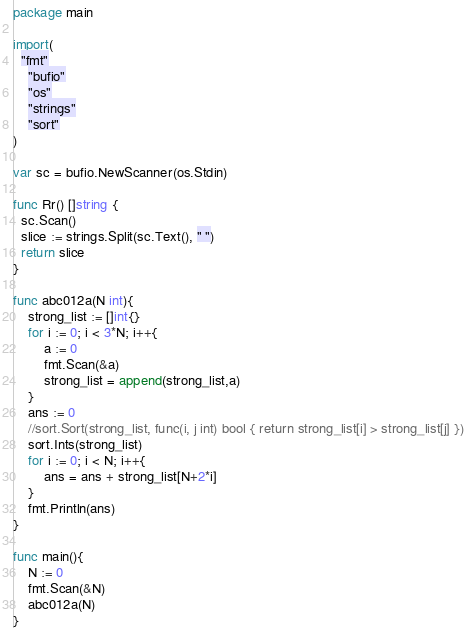<code> <loc_0><loc_0><loc_500><loc_500><_Go_>package main
 
import(
  "fmt"
	"bufio"
	"os"
	"strings"
	"sort"
)
 
var sc = bufio.NewScanner(os.Stdin)
 
func Rr() []string {
  sc.Scan()
  slice := strings.Split(sc.Text(), " ")
  return slice
}
 
func abc012a(N int){
	strong_list := []int{}
	for i := 0; i < 3*N; i++{
		a := 0
		fmt.Scan(&a)
		strong_list = append(strong_list,a)
	}
	ans := 0
	//sort.Sort(strong_list, func(i, j int) bool { return strong_list[i] > strong_list[j] })
	sort.Ints(strong_list)
	for i := 0; i < N; i++{
		ans = ans + strong_list[N+2*i]
	}
	fmt.Println(ans)
}
 
func main(){
	N := 0
	fmt.Scan(&N)
	abc012a(N)
}</code> 